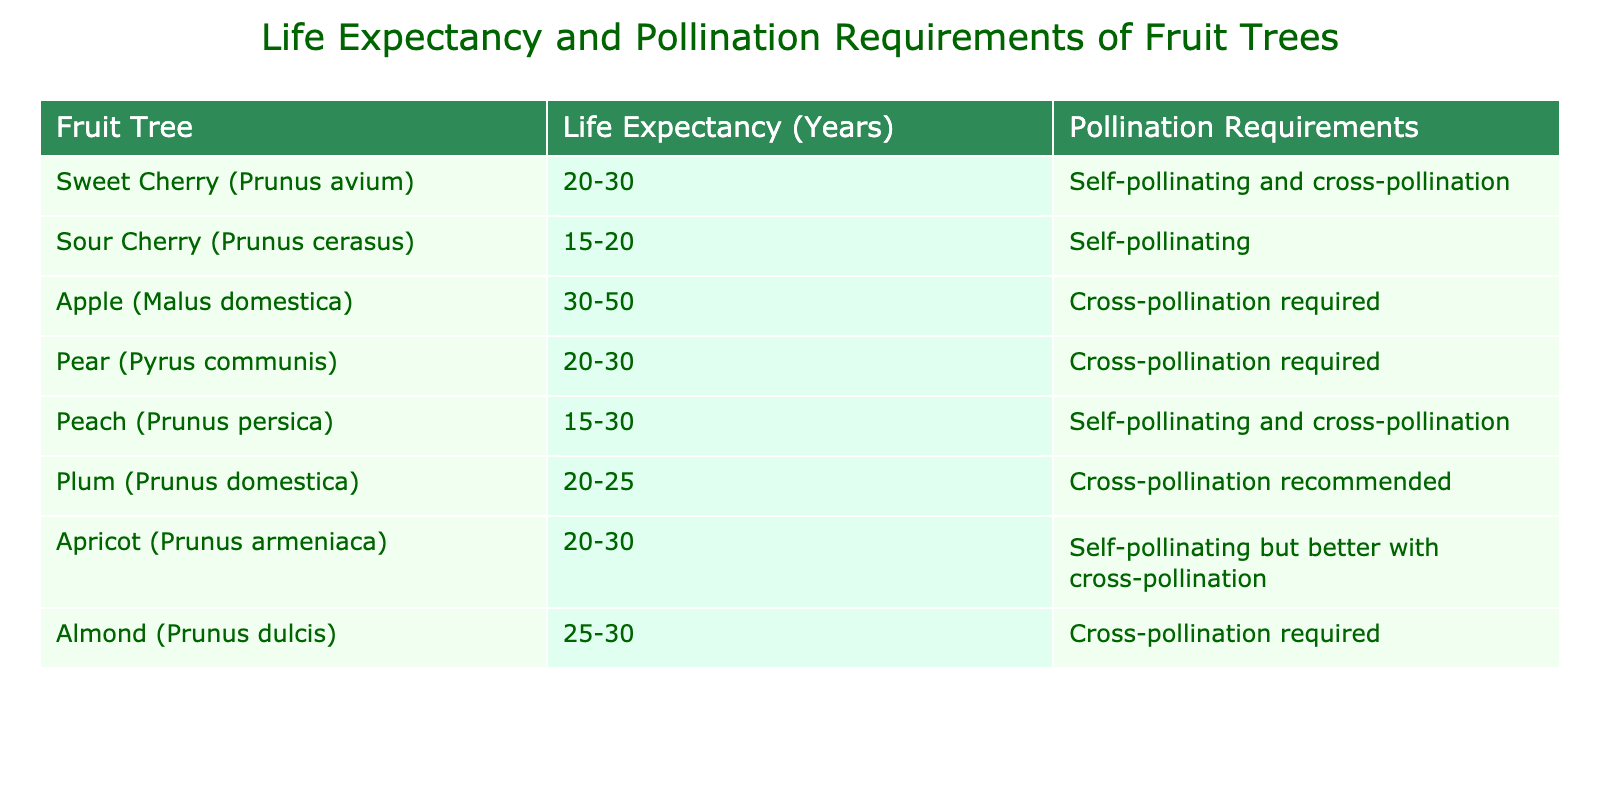What is the life expectancy range of the Sweet Cherry tree? The table indicates that the Sweet Cherry (Prunus avium) has a life expectancy of 20-30 years. This is clearly stated in the "Life Expectancy (Years)" column for this specific fruit tree.
Answer: 20-30 years Which fruit tree has the longest life expectancy? To determine the longest life expectancy, we can compare the ranges listed in the table. The Apple tree has the highest range of 30-50 years, which is greater than all other fruit trees.
Answer: Apple (30-50 years) Is the Sour Cherry tree self-pollinating? According to the table, the Sour Cherry (Prunus cerasus) is marked as self-pollinating. Therefore, it is indeed self-pollinating without any additional requirements.
Answer: Yes What is the average life expectancy of all the fruit trees listed? To find the average, we calculate the midpoints of each life expectancy range: Sweet Cherry (25), Sour Cherry (17.5), Apple (40), Pear (25), Peach (22.5), Plum (22.5), Apricot (25), Almond (27.5). Adding these yields 200, then divide by 8 (number of trees): 200/8 = 25. So, the average life expectancy is 25 years.
Answer: 25 years Do all fruit trees require cross-pollination? By looking at the "Pollination Requirements" column, we can see that not all trees require cross-pollination. Sweet Cherry, Sour Cherry, and Peach can self-pollinate, which means they do not all require cross-pollination.
Answer: No Which fruit tree requires cross-pollination among the listed fruit trees? The table lists Apple, Pear, and Almond as requiring cross-pollination. This determination comes from examining the "Pollination Requirements" column, where these specific fruit trees are noted.
Answer: Apple, Pear, Almond What is the difference in life expectancy between the Peach and the Almond? The life expectancy of Peach ranges from 15-30 years, and Almond ranges from 25-30 years. By taking the highest values (30 and 30), the difference in life expectancy is 30 - 15 = 15 years.
Answer: 15 years Is the Apricot tree better off with cross-pollination? Yes, the table specifies that while the Apricot (Prunus armeniaca) is self-pollinating, it is better with cross-pollination. This indicates that cross-pollination improves its performance.
Answer: Yes 